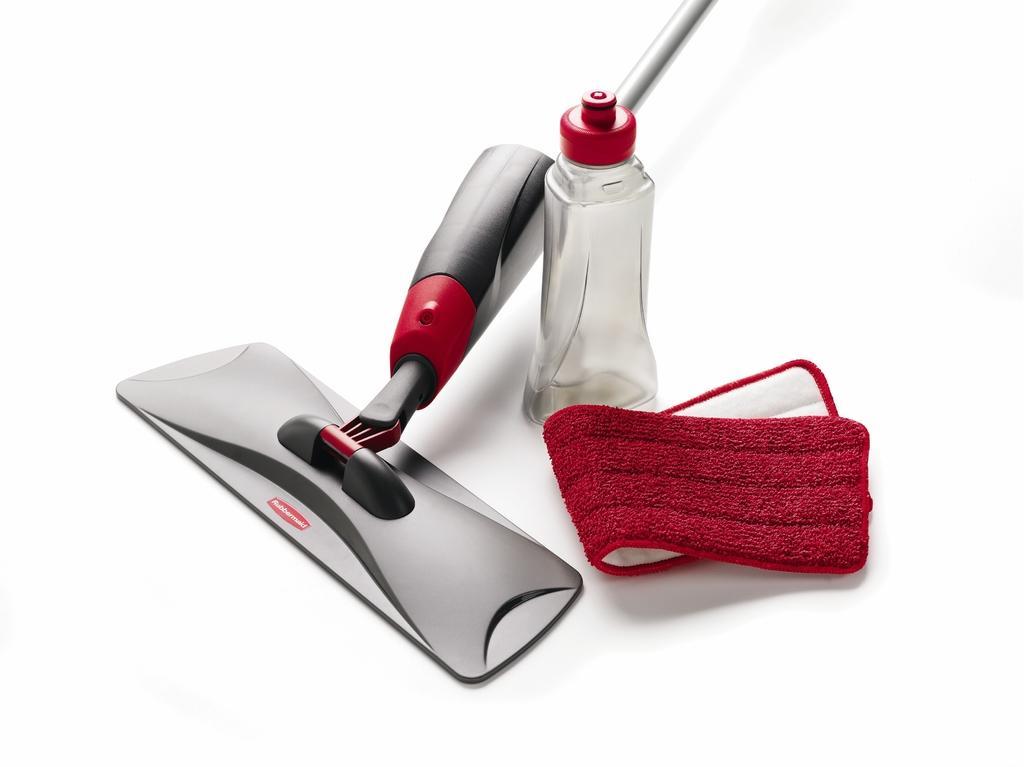How would you summarize this image in a sentence or two? In this picture we can see a spray mop, bottle, and a cloth. 